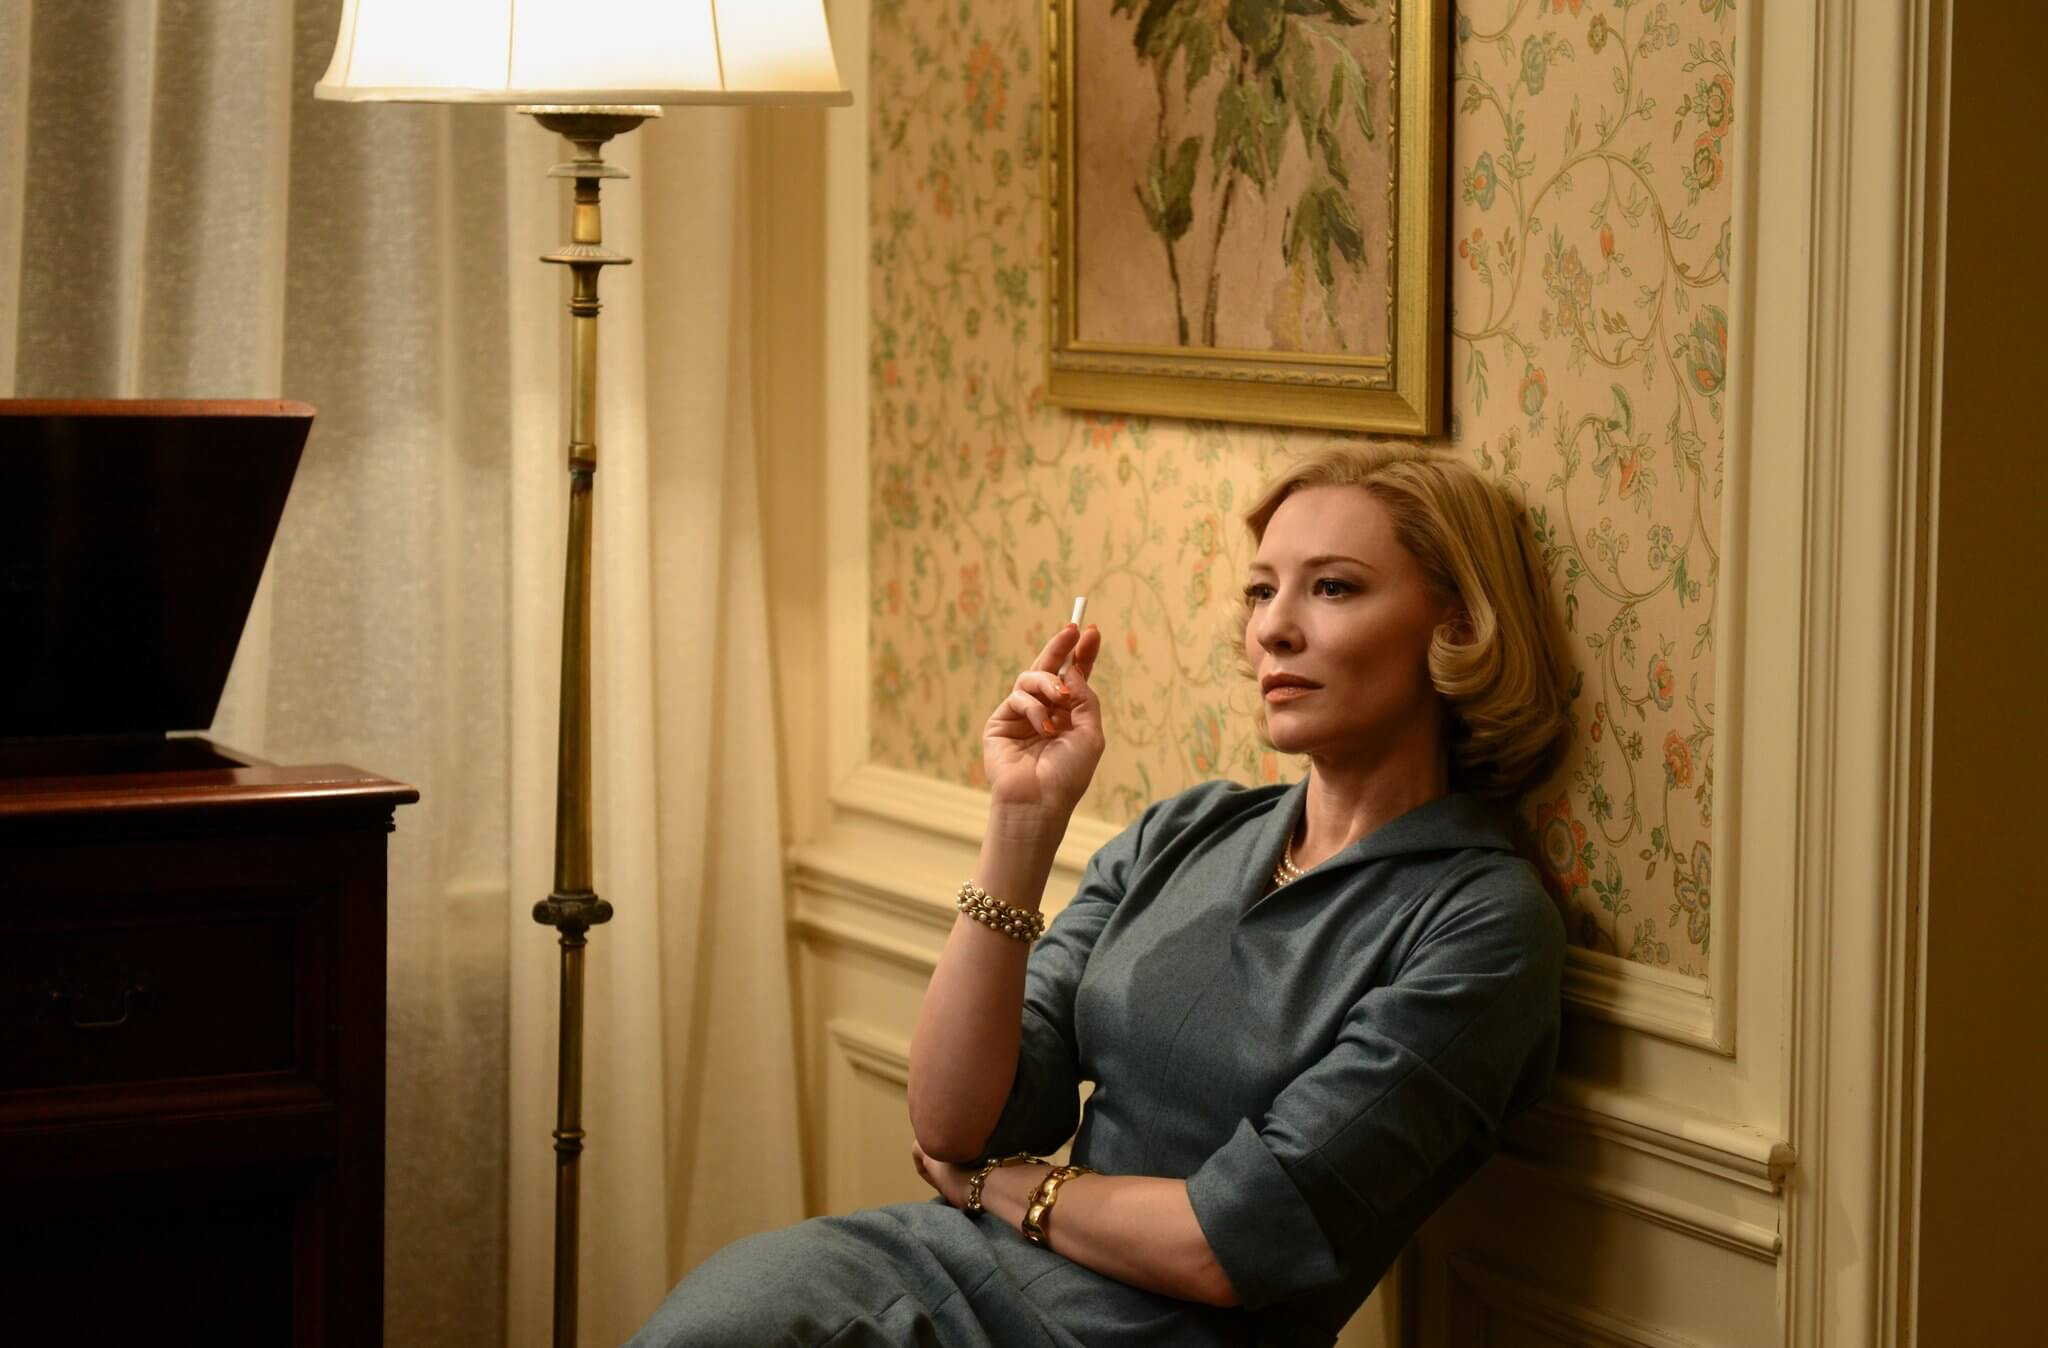What do you think the actress is thinking about in this moment? The actress's thoughtful gaze suggests she might be reflecting on a significant event or decision in her life. The setting, combined with her pensive expression and the cigarette in her hand, hints at a moment of introspection, perhaps contemplating past choices or future uncertainties. The intimate ambiance created by the floral wallpaper and the soft light from the lamp further accentuates the depth of her thoughts, inviting the viewer to ponder along with her. What can you infer about the time period based on the details in the image? The vintage elements in the image, such as the floral wallpaper, the design of the lamp, and the style of the armchair, suggest that the scene is set in a mid-20th century era. The actress's attire, a tailored blue outfit, also reflects the fashion of that time. The atmosphere and decor evoke a sense of nostalgia and provide a glimpse into a period when such interior designs were prominent, adding historical context and depth to the scene. Imagine this scene set in a dystopian future. How would the elements change? In a dystopian future, the floral wallpaper might be replaced with worn, metallic walls or screens displaying grim, utilitarian propaganda. The armchair could turn into a stark, cold metallic seat, devoid of comfort. The lamp might emanate a harsh, flickering light, adding to the oppressive atmosphere. Her cigarette might be a futuristic device, symbolizing a controlled or artificial means of solace. The actress's attire could be altered to a more uniform, monotonous outfit, reflecting a society stripped of individuality. The painting might be replaced with a digital display showing government symbols or somber imagery, reinforcing the dystopian theme, and the overall ambiance would shift from nostalgic to unsettling, highlighting the harsh realities of this imagined future. 